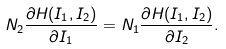<formula> <loc_0><loc_0><loc_500><loc_500>N _ { 2 } \frac { \partial H ( I _ { 1 } , I _ { 2 } ) } { \partial I _ { 1 } } = N _ { 1 } \frac { \partial H ( I _ { 1 } , I _ { 2 } ) } { \partial I _ { 2 } } .</formula> 